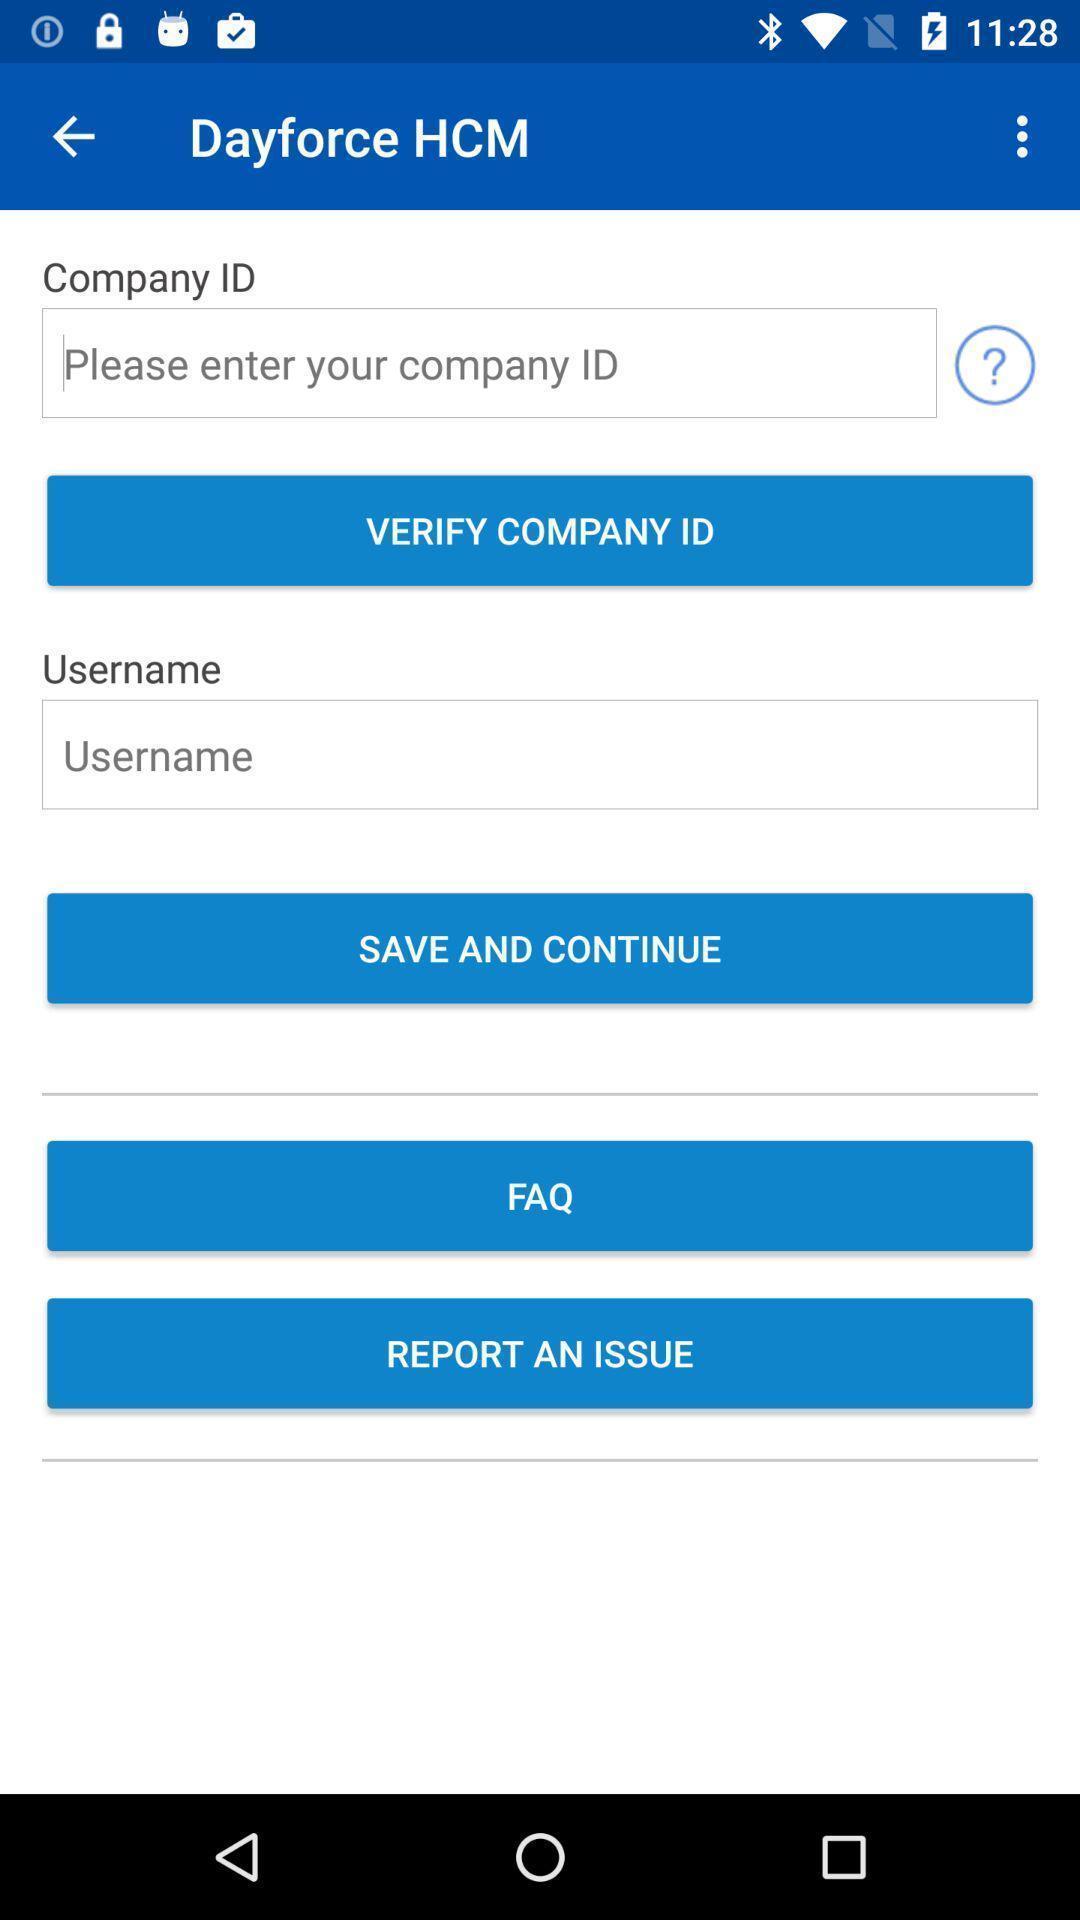Give me a summary of this screen capture. Page with option to verify the company id in application. 